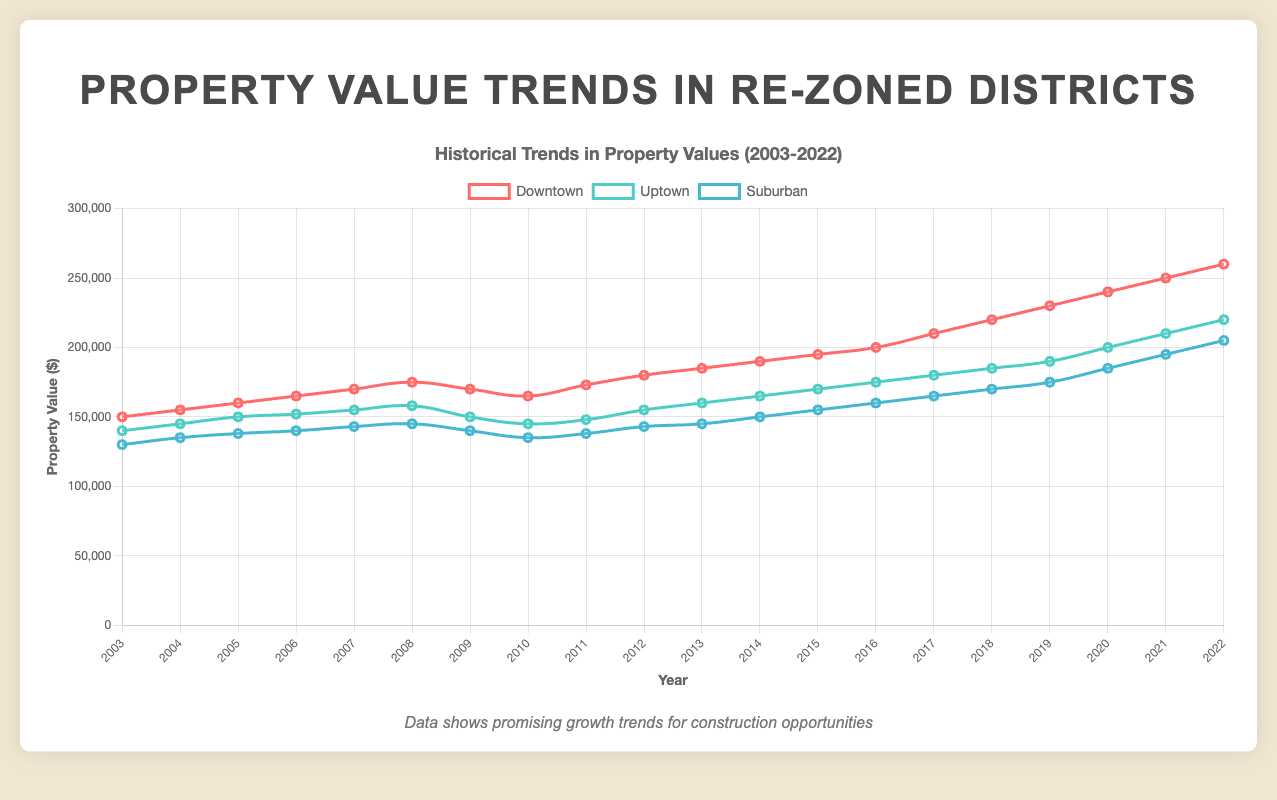What are the property values for Downtown in 2010 and 2022? Which year had the higher value and by how much? The property values for Downtown are 165,000 in 2010 and 260,000 in 2022. 2022 had the higher value. The difference is 260,000 - 165,000 = 95,000
Answer: 2022, 95,000 What trend can be observed in the property values for Uptown from 2003 to 2022? Starting at 140,000 in 2003, Uptown property values increased nearly every year, reaching 220,000 in 2022. The overall trend is a steady upward increase.
Answer: Steady upward increase Compare the property value trends in Downtown and Suburban districts from 2003 to 2022. Which district had higher growth and how can you tell? Downtown grew from 150,000 to 260,000, a 110,000 increase. Suburban grew from 130,000 to 205,000, a 75,000 increase. Downtown had higher growth, indicated by the larger increase in property value.
Answer: Downtown, larger increase How did the 2008 financial crisis impact property values in all three districts? In 2009, all districts saw a drop in property values: Downtown from 175,000 to 170,000, Uptown from 158,000 to 150,000, and Suburban from 145,000 to 140,000. The impact is visible as a dip in the chart.
Answer: Drop in all districts What is the average property value in the Uptown district from 2018 to 2022? Property values for Uptown from 2018 to 2022 are 185,000, 190,000, 200,000, 210,000, and 220,000. Their sum is 1,005,000; average is 1,005,000 / 5 = 201,000
Answer: 201,000 Which district showed the most volatility in property values over the 20-year period? Downtown showed more volatility with noticeable dips and recoveries (e.g., drops in 2009 and 2010). Uptown and Suburban had more steady trends.
Answer: Downtown What were the property values for the Suburban district in 2011 and 2014, and how did they change? Suburban property values were 138,000 in 2011 and 150,000 in 2014. The increase is 150,000 - 138,000 = 12,000
Answer: Increased by 12,000 In which year did the Downtown district see the highest property value increase? The largest increase for Downtown was between 2021 and 2022, from 250,000 to 260,000, an increase of 10,000.
Answer: 2021-2022 Based on the chart, which district's property values might suggest the best return on investment over the 20-year period? Downtown, given its substantial increase and higher end point of 260,000 from an initial 150,000
Answer: Downtown 